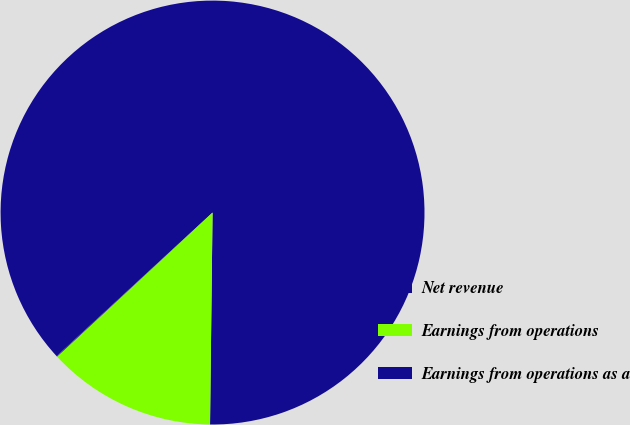Convert chart to OTSL. <chart><loc_0><loc_0><loc_500><loc_500><pie_chart><fcel>Net revenue<fcel>Earnings from operations<fcel>Earnings from operations as a<nl><fcel>87.03%<fcel>12.92%<fcel>0.05%<nl></chart> 